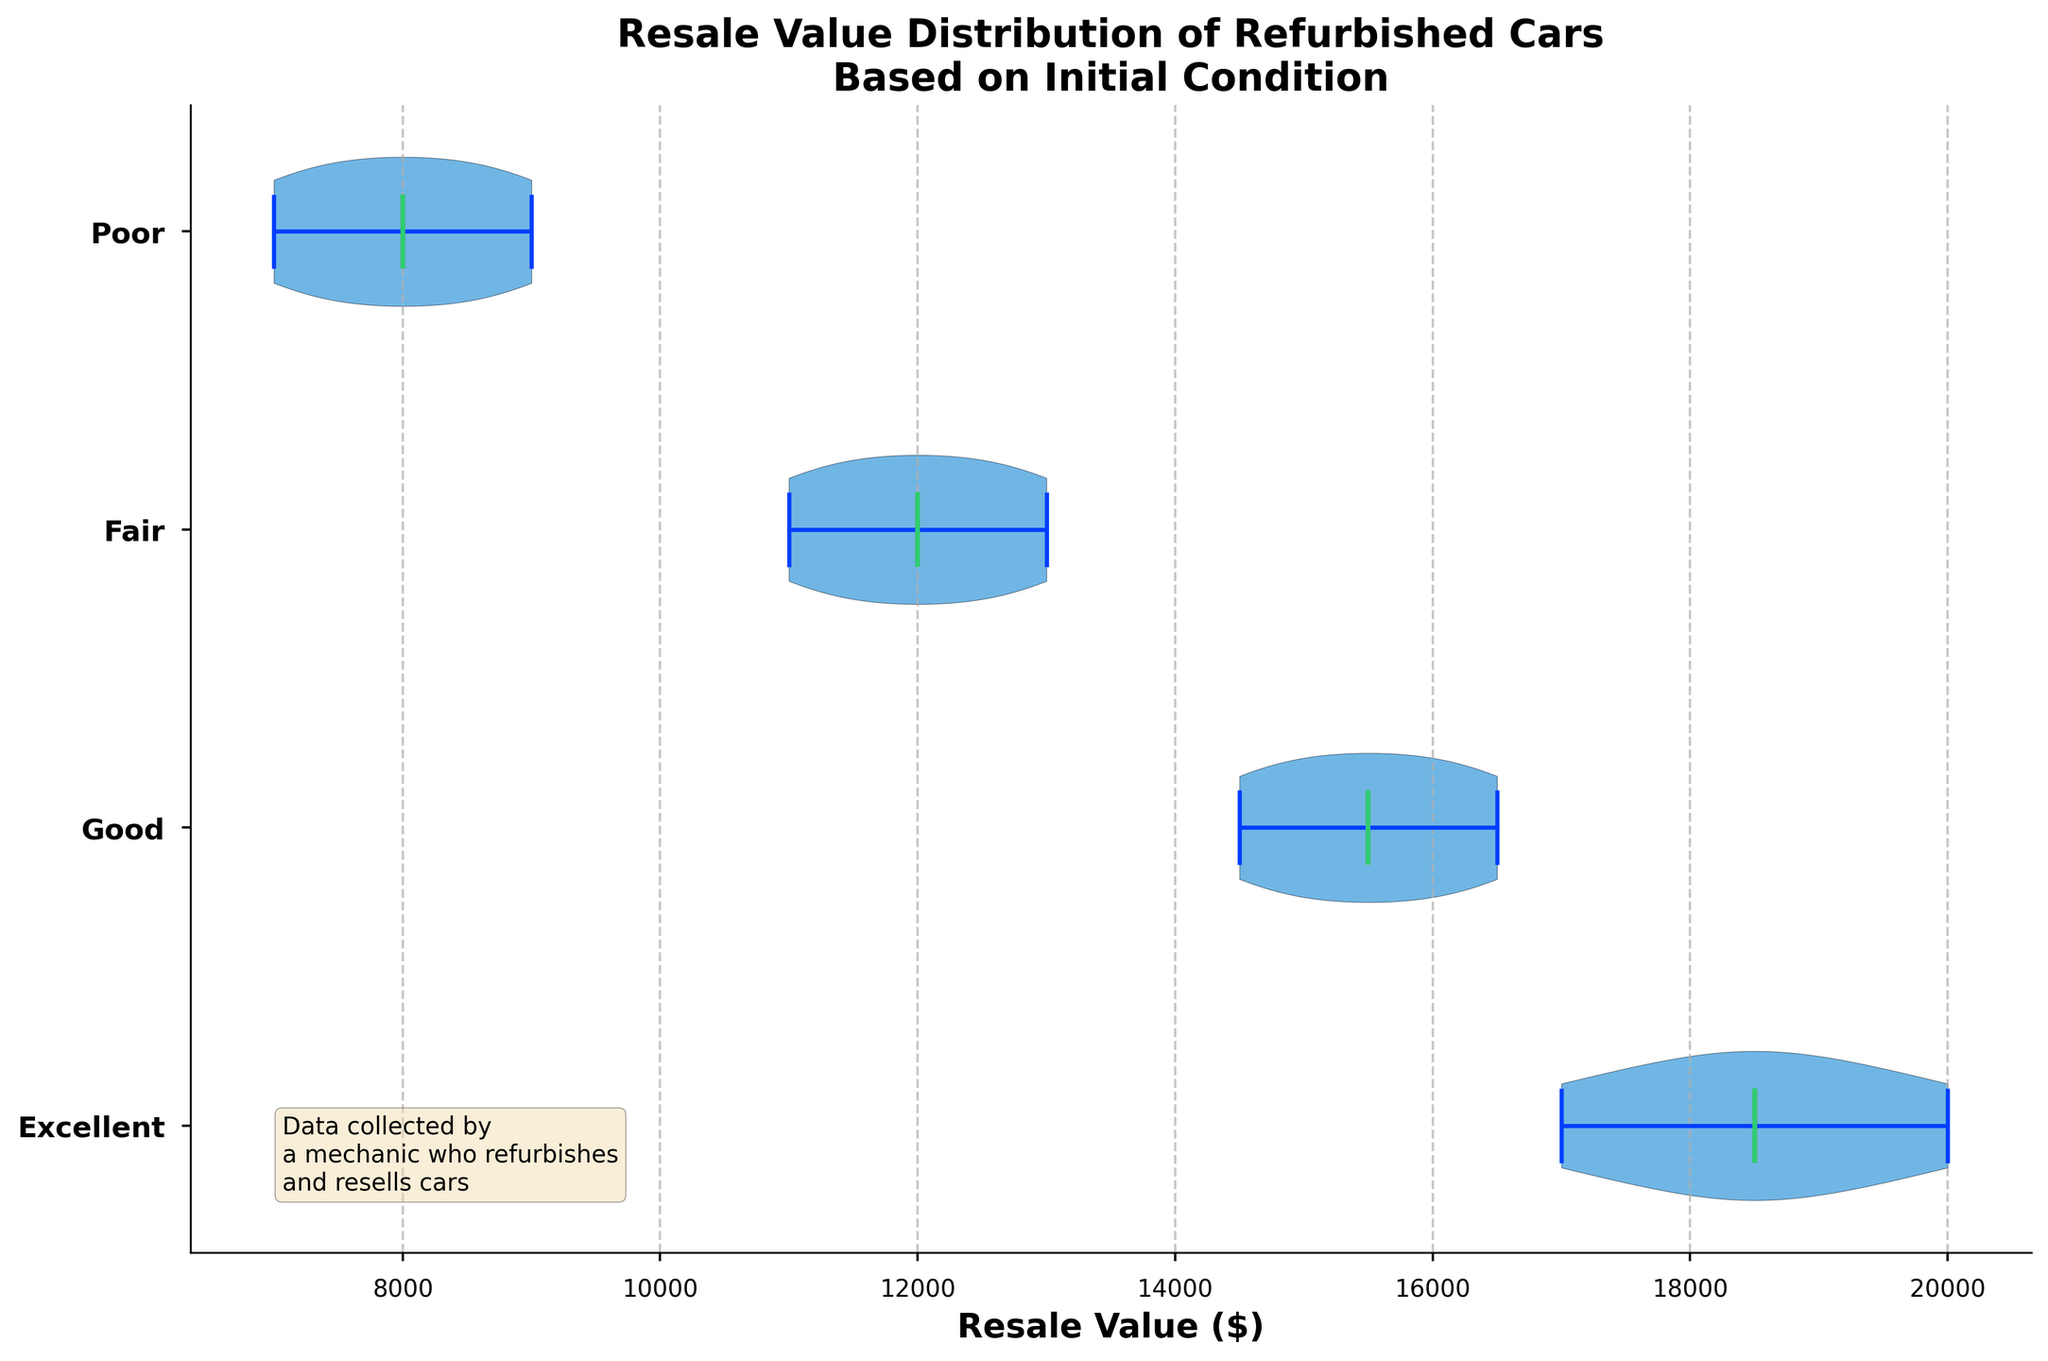what is the title of the figure? The title is usually located at the top of the figure. The text in the title provides a summary of what the chart represents. In this case, the title is "Resale Value Distribution of Refurbished Cars Based on Initial Condition."
Answer: Resale Value Distribution of Refurbished Cars Based on Initial Condition What are the different car conditions displayed in the chart? The y-axis of the chart labels different car conditions. According to the data, the conditions listed are Excellent, Good, Fair, and Poor.
Answer: Excellent, Good, Fair, Poor What's the median resale value for cars in Excellent condition? The median value in a violin plot is shown as a distinct line within each violin. For Excellent condition, the line indicates the central value.
Answer: 18500 Which car condition shows the highest average resale value? The average resale value is represented by a dot within each violin. The condition with the highest position of the dot indicates the highest average resale value.
Answer: Excellent How does the resale value distribution in 'Good' condition compare to 'Fair' condition? By observing the spread and central tendencies within the violins for 'Good' and 'Fair' conditions, we can compare their distributions. 'Good' condition has a higher and narrower distribution compared to 'Fair' condition.
Answer: Good has higher and narrower distribution compared to Fair What's the range of resale values for cars in Poor condition? The range of resale values can be determined by looking at the extremities of the violin plot for Poor condition, from the lowest to the highest values.
Answer: 7000 to 9000 Which condition exhibits the widest range in resale value? To find which condition has the widest range, compare the length from the lowest to the highest values in each violin. 'Excellent' has the widest range because its extremes are the furthest apart.
Answer: Excellent Are the resale values in the 'Fair' condition normally distributed? The shape of the violin plot can indicate if the data is normally distributed. A normal distribution would have a symmetric bell curve shape. The 'Fair' condition appears somewhat symmetric but is not a perfect bell shape.
Answer: No Which condition has the most asymmetric distribution in resale values? By looking at the shape of the violins, 'Poor' condition shows the most asymmetry, with most values clustered towards a lower range.
Answer: Poor If you were to resell a refurbished car, which condition would you expect to provide the most consistent resale value? Consistency in resale value can be inferred from the narrowness of the range in the violin plot. 'Good' condition has the most consistent resale value, as indicated by a relatively narrow shape.
Answer: Good 